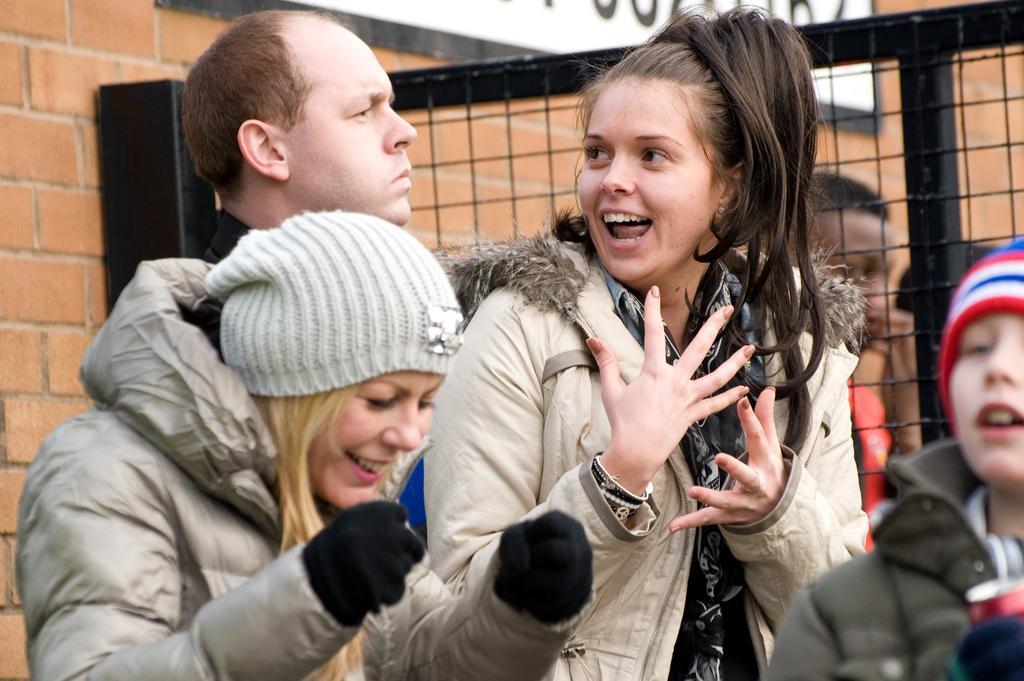How would you summarize this image in a sentence or two? In the center of the image we can see a few people are standing and they are in different costumes. Among them, we can see two people are smiling. In the background there is a brick wall, banner, fence, one person standing and a few other objects. 